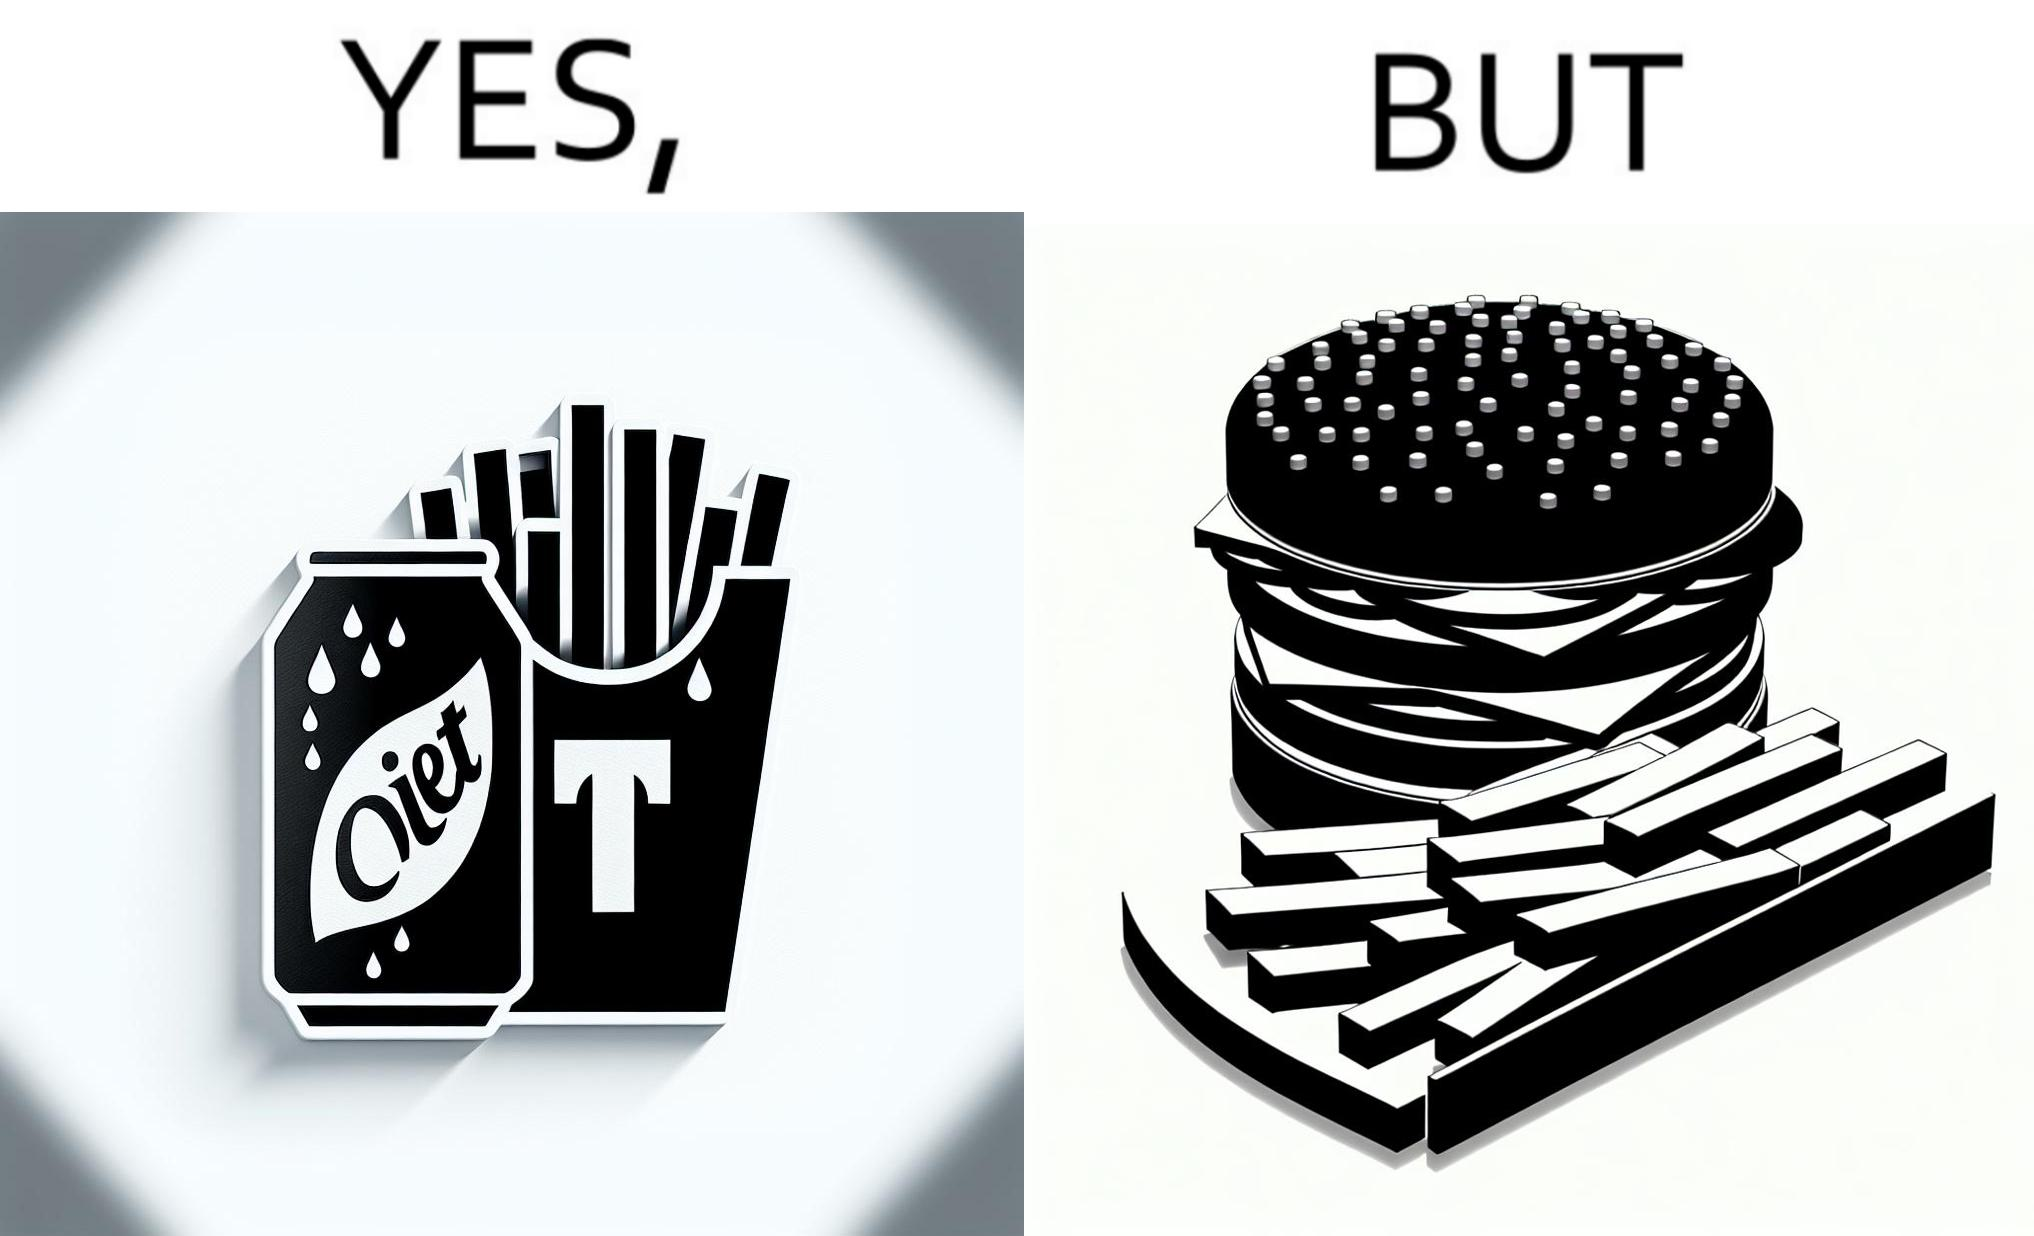Is there satirical content in this image? Yes, this image is satirical. 